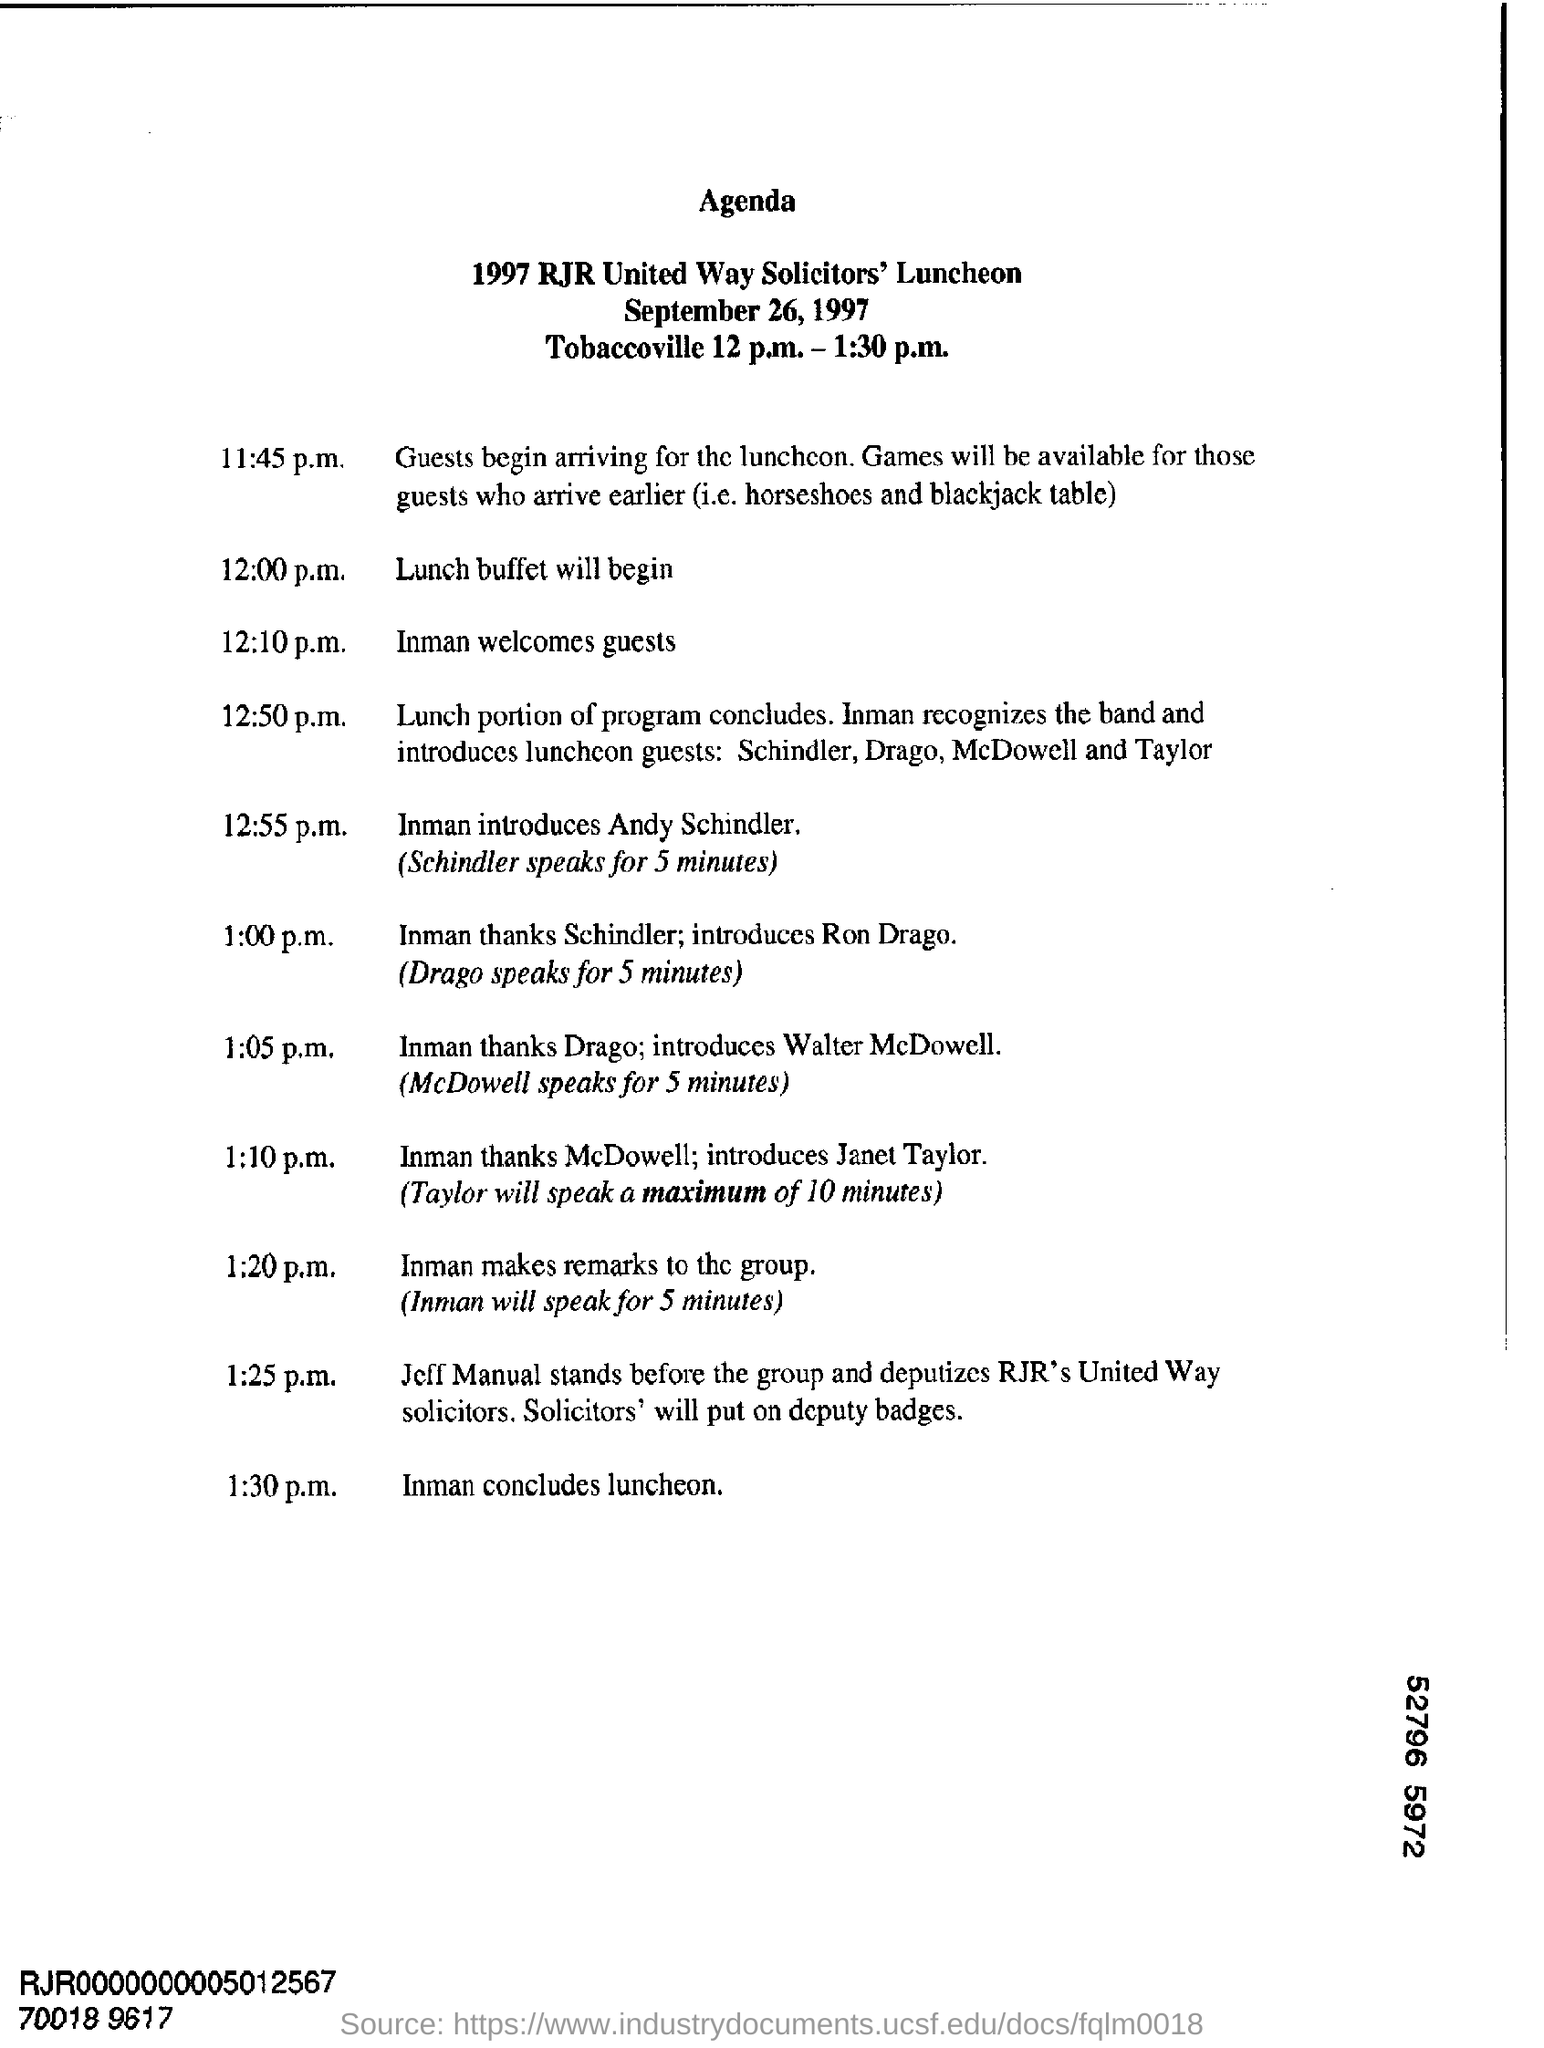List a handful of essential elements in this visual. The agenda for the 1997 RJR United Way Solicitors' Luncheon is not specified. At 12:55 p.m., Inman introduces Schindler. 